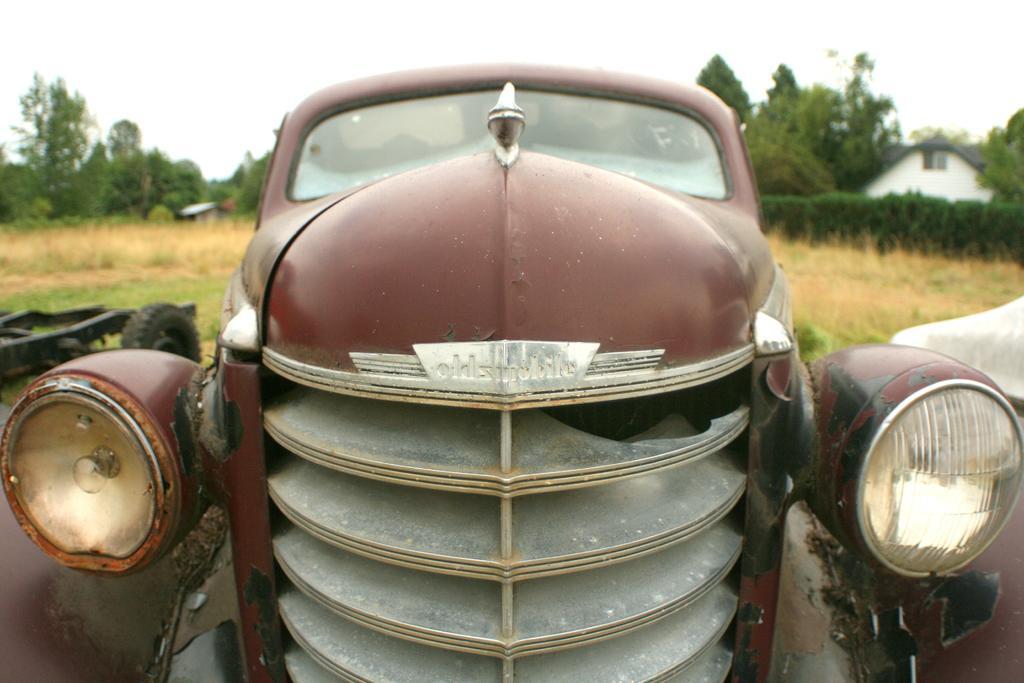Describe this image in one or two sentences. In this picture we can see a vehicle and headlights. In the background of the image we can see grass, plants, trees, house and sky. 